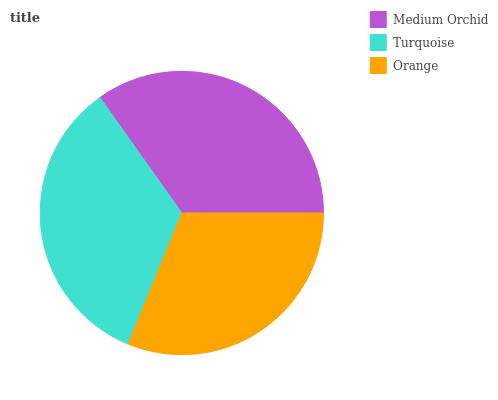Is Orange the minimum?
Answer yes or no. Yes. Is Medium Orchid the maximum?
Answer yes or no. Yes. Is Turquoise the minimum?
Answer yes or no. No. Is Turquoise the maximum?
Answer yes or no. No. Is Medium Orchid greater than Turquoise?
Answer yes or no. Yes. Is Turquoise less than Medium Orchid?
Answer yes or no. Yes. Is Turquoise greater than Medium Orchid?
Answer yes or no. No. Is Medium Orchid less than Turquoise?
Answer yes or no. No. Is Turquoise the high median?
Answer yes or no. Yes. Is Turquoise the low median?
Answer yes or no. Yes. Is Orange the high median?
Answer yes or no. No. Is Medium Orchid the low median?
Answer yes or no. No. 